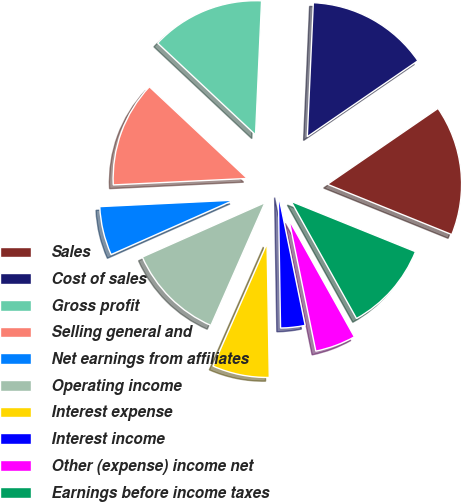Convert chart. <chart><loc_0><loc_0><loc_500><loc_500><pie_chart><fcel>Sales<fcel>Cost of sales<fcel>Gross profit<fcel>Selling general and<fcel>Net earnings from affiliates<fcel>Operating income<fcel>Interest expense<fcel>Interest income<fcel>Other (expense) income net<fcel>Earnings before income taxes<nl><fcel>15.69%<fcel>14.71%<fcel>13.73%<fcel>12.75%<fcel>5.88%<fcel>11.76%<fcel>6.86%<fcel>2.94%<fcel>4.9%<fcel>10.78%<nl></chart> 